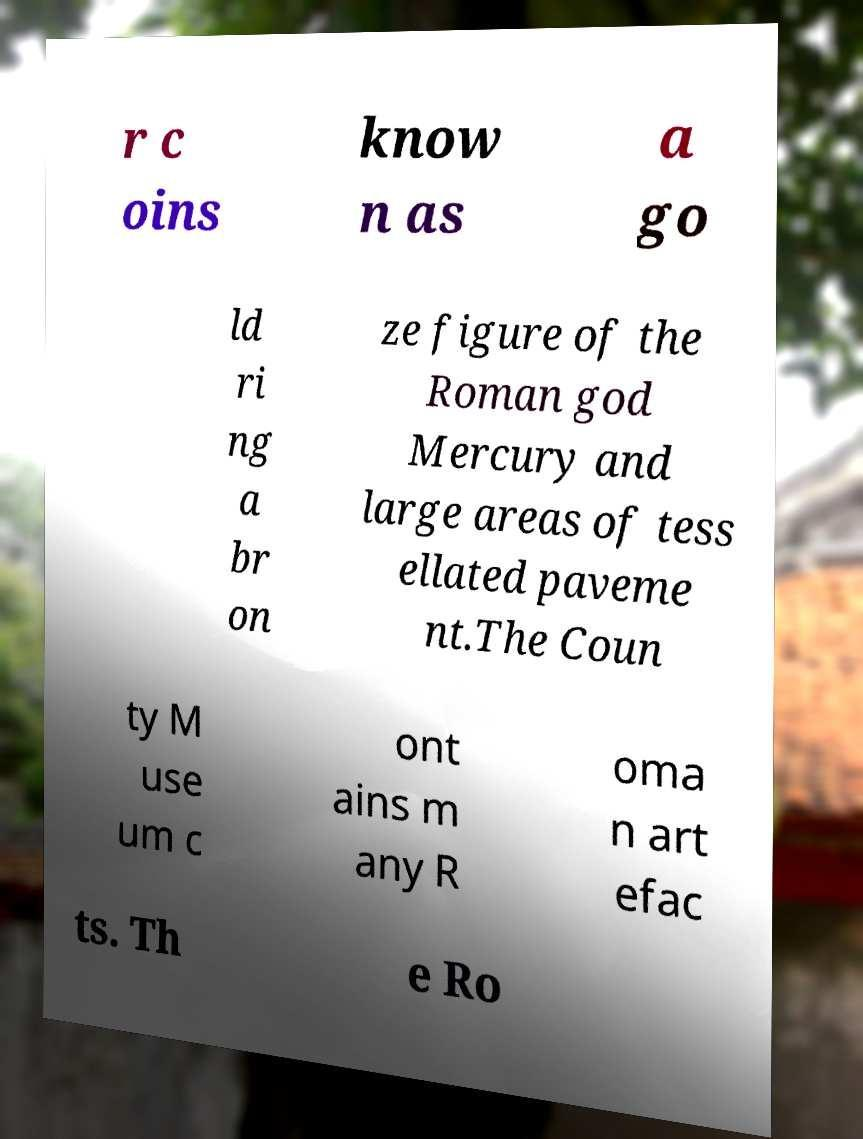Can you read and provide the text displayed in the image?This photo seems to have some interesting text. Can you extract and type it out for me? r c oins know n as a go ld ri ng a br on ze figure of the Roman god Mercury and large areas of tess ellated paveme nt.The Coun ty M use um c ont ains m any R oma n art efac ts. Th e Ro 